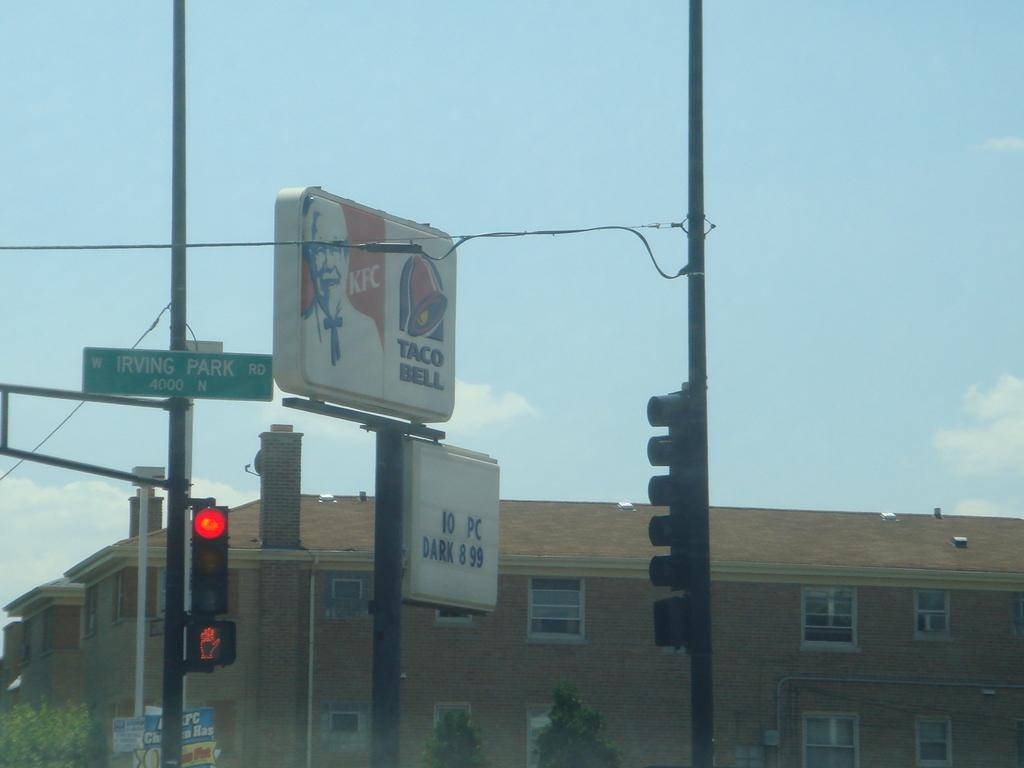What restaurants are at the intersection?
Your response must be concise. Kfc taco bell. What street is the intersection?
Offer a terse response. Irving park. 